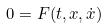<formula> <loc_0><loc_0><loc_500><loc_500>0 = F ( t , x , \dot { x } )</formula> 